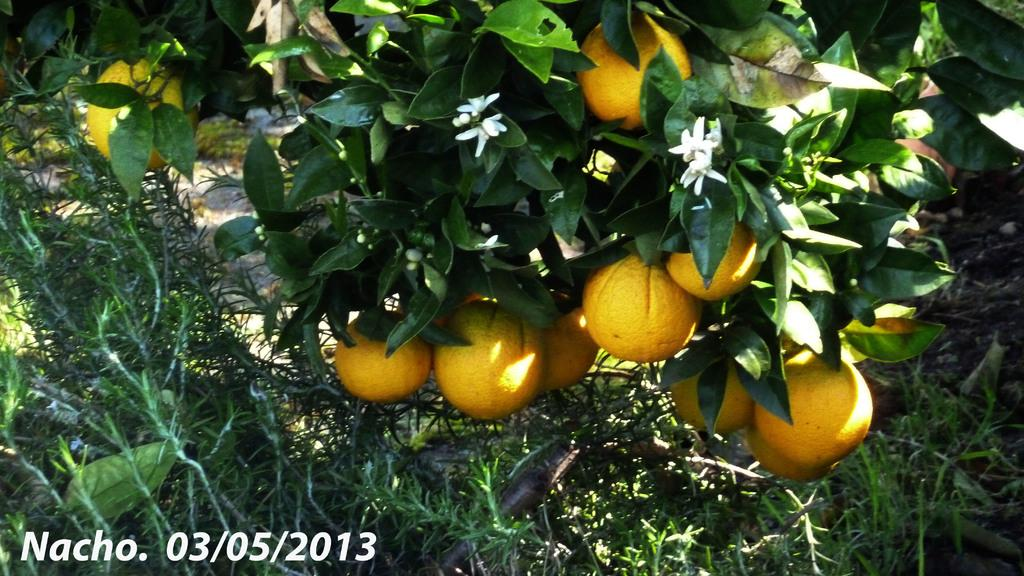What type of produce can be seen on the trees in the image? There are fruits on the trees in the image. What color are the fruits? The fruits are yellow in color. What other types of vegetation are present in the image? There are plants in the image. What color are the plants? The plants are green in color. What type of wheel can be seen in the image? There is no wheel present in the image; it features fruits on trees and green plants. Can you tell me the name of the son in the image? There is no person, let alone a son, present in the image. 